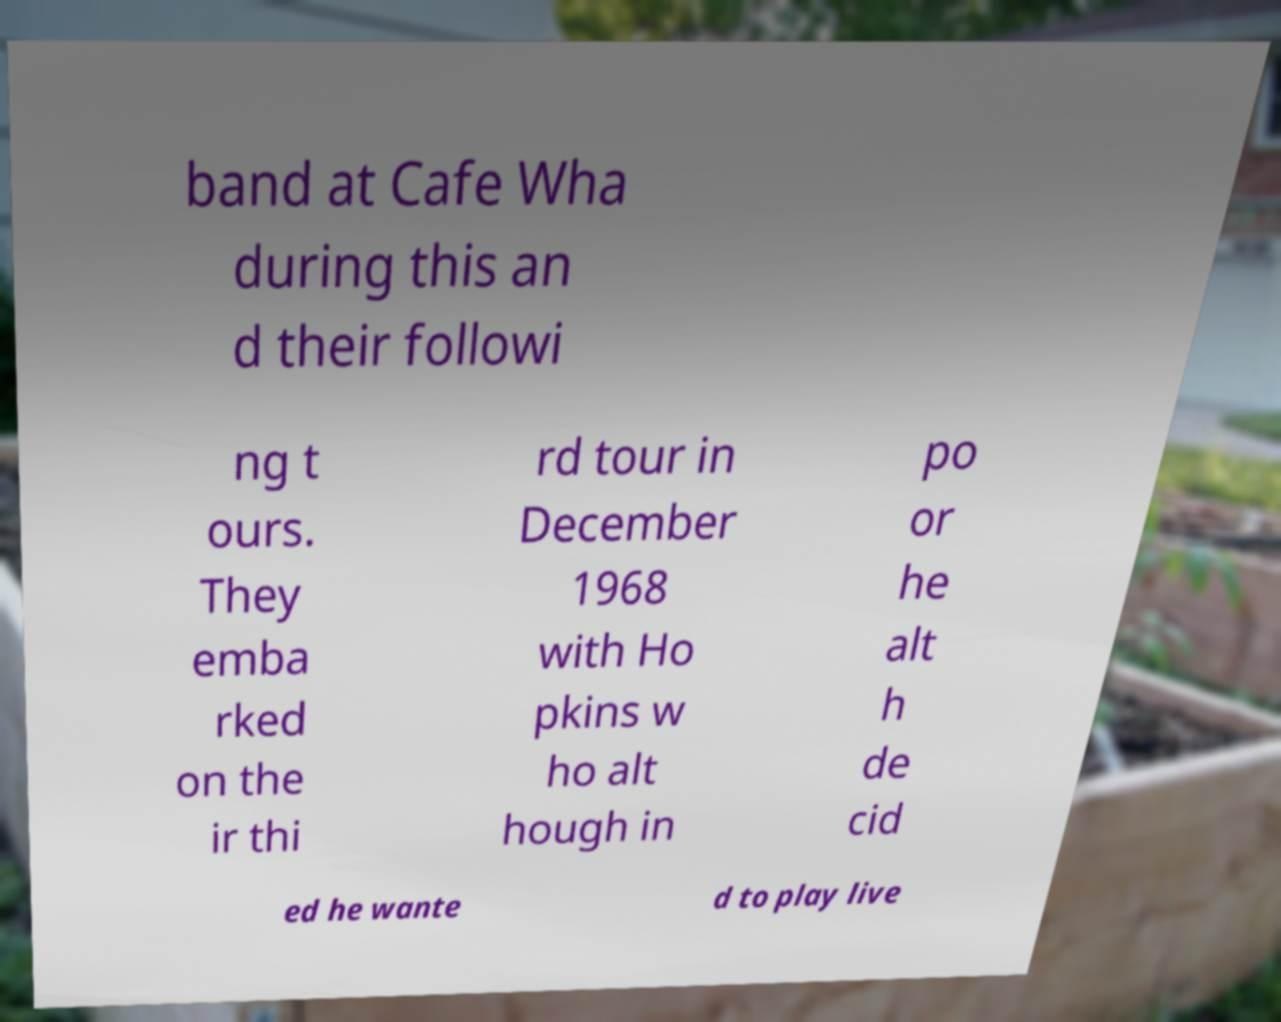What messages or text are displayed in this image? I need them in a readable, typed format. band at Cafe Wha during this an d their followi ng t ours. They emba rked on the ir thi rd tour in December 1968 with Ho pkins w ho alt hough in po or he alt h de cid ed he wante d to play live 